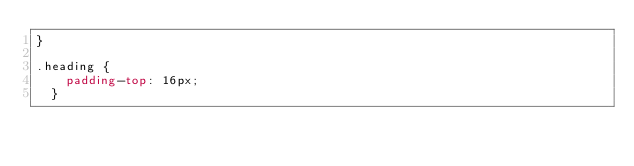<code> <loc_0><loc_0><loc_500><loc_500><_CSS_>}

.heading {
    padding-top: 16px;
  }</code> 